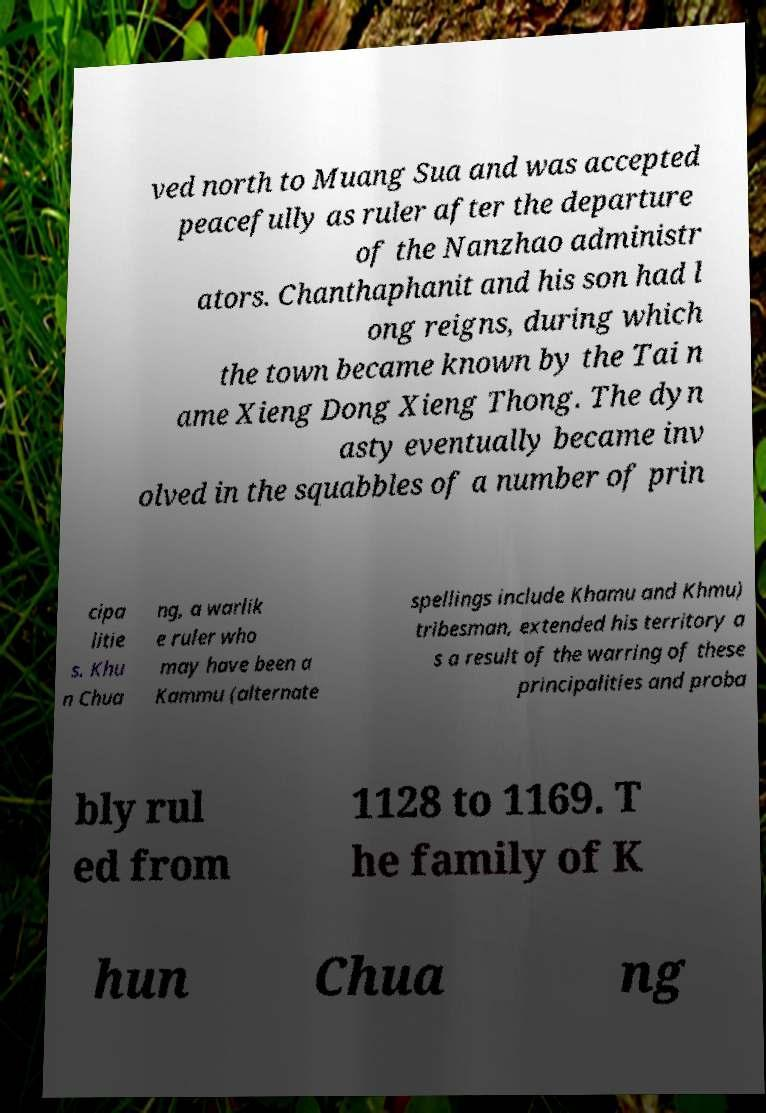Please identify and transcribe the text found in this image. ved north to Muang Sua and was accepted peacefully as ruler after the departure of the Nanzhao administr ators. Chanthaphanit and his son had l ong reigns, during which the town became known by the Tai n ame Xieng Dong Xieng Thong. The dyn asty eventually became inv olved in the squabbles of a number of prin cipa litie s. Khu n Chua ng, a warlik e ruler who may have been a Kammu (alternate spellings include Khamu and Khmu) tribesman, extended his territory a s a result of the warring of these principalities and proba bly rul ed from 1128 to 1169. T he family of K hun Chua ng 